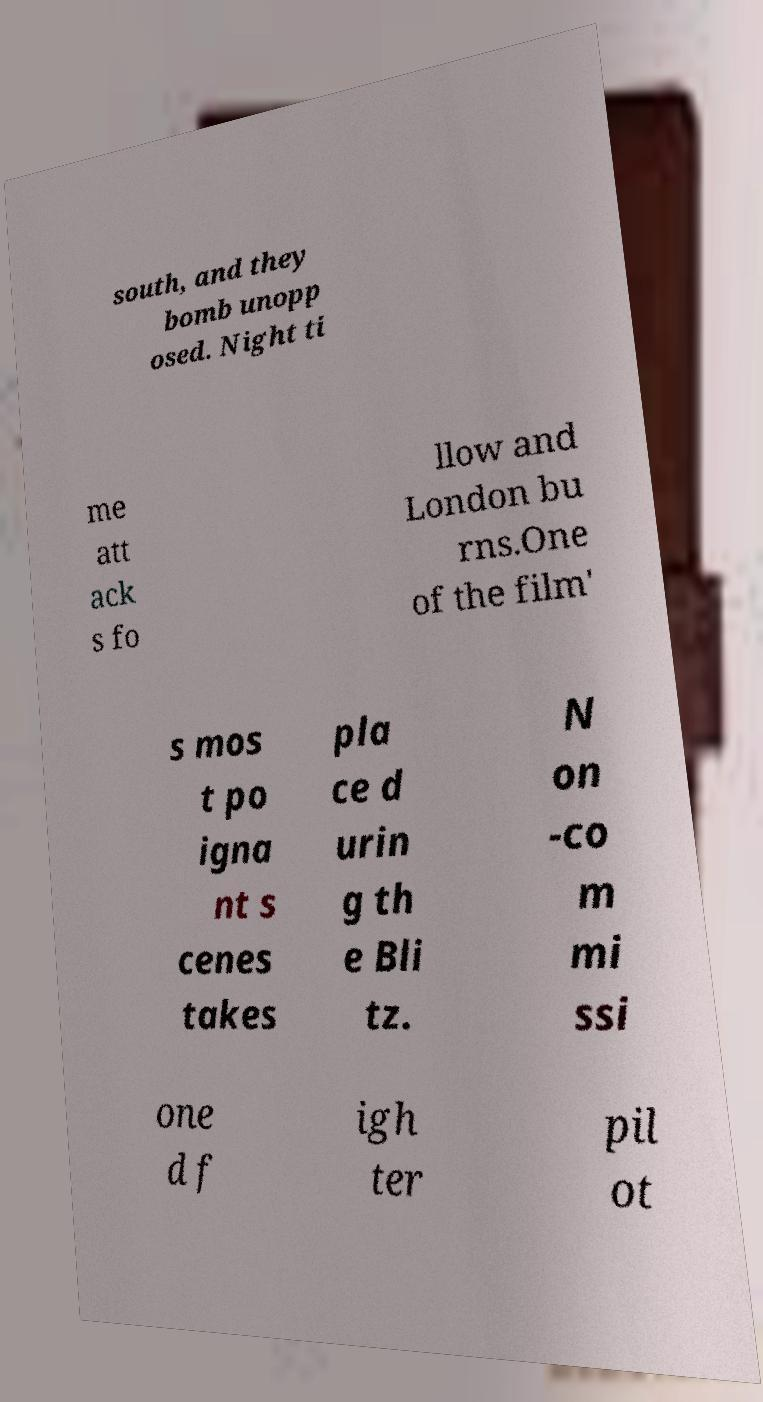Can you accurately transcribe the text from the provided image for me? south, and they bomb unopp osed. Night ti me att ack s fo llow and London bu rns.One of the film' s mos t po igna nt s cenes takes pla ce d urin g th e Bli tz. N on -co m mi ssi one d f igh ter pil ot 